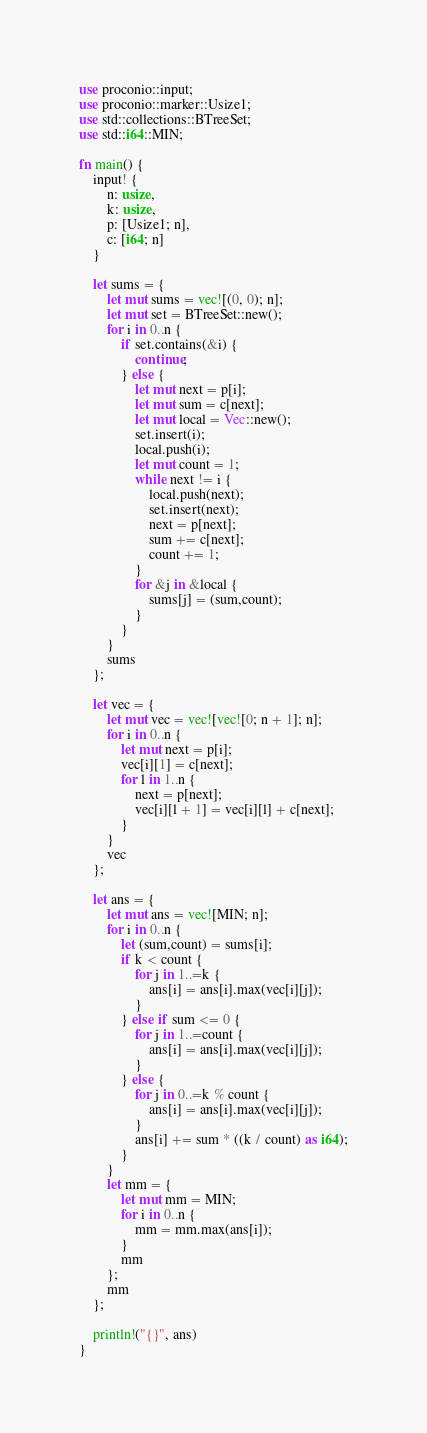<code> <loc_0><loc_0><loc_500><loc_500><_Rust_>use proconio::input;
use proconio::marker::Usize1;
use std::collections::BTreeSet;
use std::i64::MIN;

fn main() {
    input! {
        n: usize,
        k: usize,
        p: [Usize1; n],
        c: [i64; n]
    }

    let sums = {
        let mut sums = vec![(0, 0); n];
        let mut set = BTreeSet::new();
        for i in 0..n {
            if set.contains(&i) {
                continue;
            } else {
                let mut next = p[i];
                let mut sum = c[next];
                let mut local = Vec::new();
                set.insert(i);
                local.push(i);
                let mut count = 1;
                while next != i {
                    local.push(next);
                    set.insert(next);
                    next = p[next];
                    sum += c[next];
                    count += 1;
                }
                for &j in &local {
                    sums[j] = (sum,count);
                }
            }
        }
        sums
    };

    let vec = {
        let mut vec = vec![vec![0; n + 1]; n];
        for i in 0..n {
            let mut next = p[i];
            vec[i][1] = c[next];
            for l in 1..n {
                next = p[next];
                vec[i][l + 1] = vec[i][l] + c[next];
            }
        }
        vec
    };

    let ans = {
        let mut ans = vec![MIN; n];
        for i in 0..n {
            let (sum,count) = sums[i];
            if k < count {
                for j in 1..=k {
                    ans[i] = ans[i].max(vec[i][j]);
                }
            } else if sum <= 0 {
                for j in 1..=count {
                    ans[i] = ans[i].max(vec[i][j]);
                }
            } else {
                for j in 0..=k % count {
                    ans[i] = ans[i].max(vec[i][j]);
                }
                ans[i] += sum * ((k / count) as i64);
            }
        }
        let mm = {
            let mut mm = MIN;
            for i in 0..n {
                mm = mm.max(ans[i]);
            }
            mm
        };
        mm
    };

    println!("{}", ans)
}
</code> 